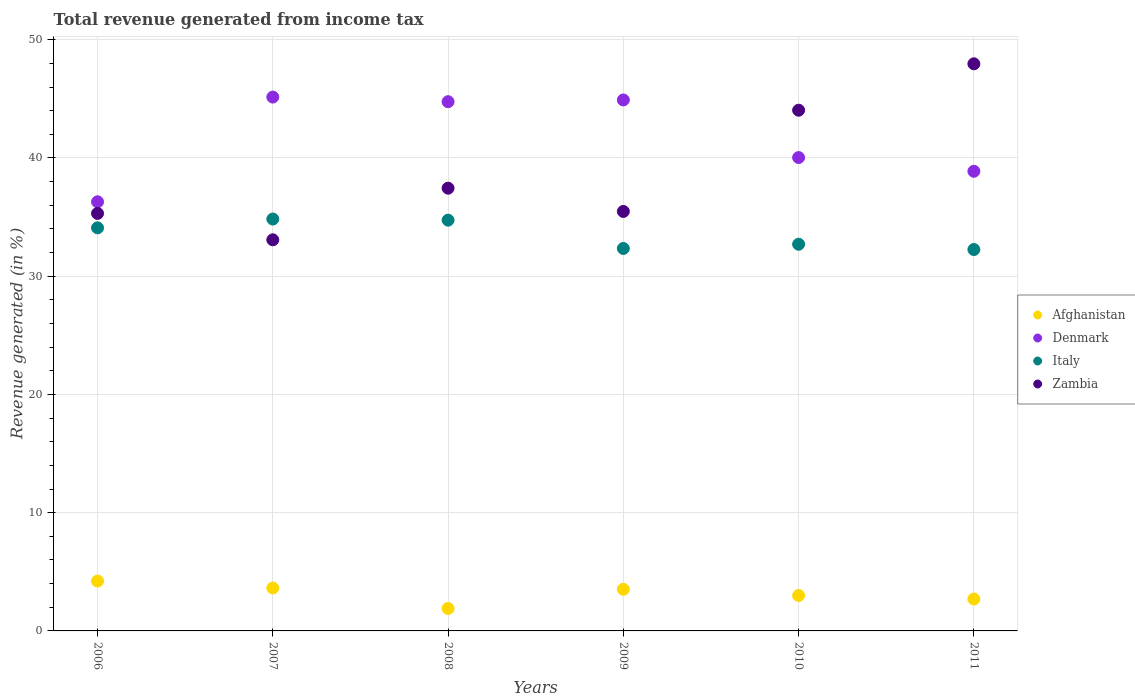Is the number of dotlines equal to the number of legend labels?
Your answer should be very brief. Yes. What is the total revenue generated in Denmark in 2009?
Keep it short and to the point. 44.91. Across all years, what is the maximum total revenue generated in Italy?
Your answer should be very brief. 34.84. Across all years, what is the minimum total revenue generated in Italy?
Keep it short and to the point. 32.26. In which year was the total revenue generated in Denmark maximum?
Your answer should be compact. 2007. In which year was the total revenue generated in Afghanistan minimum?
Provide a short and direct response. 2008. What is the total total revenue generated in Denmark in the graph?
Provide a succinct answer. 250.03. What is the difference between the total revenue generated in Italy in 2006 and that in 2010?
Provide a short and direct response. 1.39. What is the difference between the total revenue generated in Denmark in 2011 and the total revenue generated in Italy in 2010?
Your response must be concise. 6.17. What is the average total revenue generated in Denmark per year?
Your answer should be compact. 41.67. In the year 2011, what is the difference between the total revenue generated in Italy and total revenue generated in Zambia?
Your response must be concise. -15.71. In how many years, is the total revenue generated in Zambia greater than 48 %?
Offer a terse response. 0. What is the ratio of the total revenue generated in Afghanistan in 2007 to that in 2010?
Provide a succinct answer. 1.21. Is the total revenue generated in Zambia in 2006 less than that in 2010?
Give a very brief answer. Yes. What is the difference between the highest and the second highest total revenue generated in Denmark?
Ensure brevity in your answer.  0.24. What is the difference between the highest and the lowest total revenue generated in Italy?
Offer a very short reply. 2.58. Is it the case that in every year, the sum of the total revenue generated in Afghanistan and total revenue generated in Zambia  is greater than the total revenue generated in Italy?
Make the answer very short. Yes. Is the total revenue generated in Italy strictly less than the total revenue generated in Afghanistan over the years?
Offer a very short reply. No. How many dotlines are there?
Provide a short and direct response. 4. Does the graph contain any zero values?
Offer a terse response. No. Does the graph contain grids?
Give a very brief answer. Yes. How are the legend labels stacked?
Ensure brevity in your answer.  Vertical. What is the title of the graph?
Your response must be concise. Total revenue generated from income tax. What is the label or title of the X-axis?
Ensure brevity in your answer.  Years. What is the label or title of the Y-axis?
Offer a terse response. Revenue generated (in %). What is the Revenue generated (in %) of Afghanistan in 2006?
Provide a short and direct response. 4.22. What is the Revenue generated (in %) of Denmark in 2006?
Your answer should be compact. 36.29. What is the Revenue generated (in %) in Italy in 2006?
Offer a very short reply. 34.09. What is the Revenue generated (in %) in Zambia in 2006?
Keep it short and to the point. 35.31. What is the Revenue generated (in %) in Afghanistan in 2007?
Make the answer very short. 3.63. What is the Revenue generated (in %) in Denmark in 2007?
Offer a terse response. 45.15. What is the Revenue generated (in %) of Italy in 2007?
Give a very brief answer. 34.84. What is the Revenue generated (in %) of Zambia in 2007?
Make the answer very short. 33.08. What is the Revenue generated (in %) of Afghanistan in 2008?
Your response must be concise. 1.9. What is the Revenue generated (in %) in Denmark in 2008?
Your answer should be very brief. 44.76. What is the Revenue generated (in %) of Italy in 2008?
Your answer should be very brief. 34.74. What is the Revenue generated (in %) in Zambia in 2008?
Your answer should be very brief. 37.45. What is the Revenue generated (in %) of Afghanistan in 2009?
Offer a very short reply. 3.52. What is the Revenue generated (in %) in Denmark in 2009?
Your answer should be compact. 44.91. What is the Revenue generated (in %) of Italy in 2009?
Give a very brief answer. 32.35. What is the Revenue generated (in %) of Zambia in 2009?
Your answer should be compact. 35.48. What is the Revenue generated (in %) in Afghanistan in 2010?
Make the answer very short. 3. What is the Revenue generated (in %) in Denmark in 2010?
Offer a very short reply. 40.04. What is the Revenue generated (in %) in Italy in 2010?
Make the answer very short. 32.71. What is the Revenue generated (in %) in Zambia in 2010?
Offer a terse response. 44.04. What is the Revenue generated (in %) in Afghanistan in 2011?
Your response must be concise. 2.7. What is the Revenue generated (in %) in Denmark in 2011?
Offer a very short reply. 38.88. What is the Revenue generated (in %) of Italy in 2011?
Provide a short and direct response. 32.26. What is the Revenue generated (in %) in Zambia in 2011?
Provide a succinct answer. 47.97. Across all years, what is the maximum Revenue generated (in %) of Afghanistan?
Your answer should be compact. 4.22. Across all years, what is the maximum Revenue generated (in %) in Denmark?
Provide a short and direct response. 45.15. Across all years, what is the maximum Revenue generated (in %) of Italy?
Make the answer very short. 34.84. Across all years, what is the maximum Revenue generated (in %) of Zambia?
Offer a terse response. 47.97. Across all years, what is the minimum Revenue generated (in %) of Afghanistan?
Ensure brevity in your answer.  1.9. Across all years, what is the minimum Revenue generated (in %) of Denmark?
Your response must be concise. 36.29. Across all years, what is the minimum Revenue generated (in %) in Italy?
Provide a short and direct response. 32.26. Across all years, what is the minimum Revenue generated (in %) in Zambia?
Your answer should be compact. 33.08. What is the total Revenue generated (in %) in Afghanistan in the graph?
Provide a succinct answer. 18.97. What is the total Revenue generated (in %) in Denmark in the graph?
Offer a terse response. 250.03. What is the total Revenue generated (in %) of Italy in the graph?
Offer a terse response. 200.99. What is the total Revenue generated (in %) in Zambia in the graph?
Offer a terse response. 233.33. What is the difference between the Revenue generated (in %) of Afghanistan in 2006 and that in 2007?
Provide a succinct answer. 0.59. What is the difference between the Revenue generated (in %) in Denmark in 2006 and that in 2007?
Keep it short and to the point. -8.86. What is the difference between the Revenue generated (in %) in Italy in 2006 and that in 2007?
Make the answer very short. -0.74. What is the difference between the Revenue generated (in %) in Zambia in 2006 and that in 2007?
Offer a very short reply. 2.23. What is the difference between the Revenue generated (in %) of Afghanistan in 2006 and that in 2008?
Ensure brevity in your answer.  2.32. What is the difference between the Revenue generated (in %) in Denmark in 2006 and that in 2008?
Make the answer very short. -8.47. What is the difference between the Revenue generated (in %) of Italy in 2006 and that in 2008?
Your response must be concise. -0.65. What is the difference between the Revenue generated (in %) of Zambia in 2006 and that in 2008?
Offer a terse response. -2.13. What is the difference between the Revenue generated (in %) of Afghanistan in 2006 and that in 2009?
Offer a very short reply. 0.7. What is the difference between the Revenue generated (in %) in Denmark in 2006 and that in 2009?
Give a very brief answer. -8.61. What is the difference between the Revenue generated (in %) in Italy in 2006 and that in 2009?
Provide a short and direct response. 1.74. What is the difference between the Revenue generated (in %) in Zambia in 2006 and that in 2009?
Provide a succinct answer. -0.17. What is the difference between the Revenue generated (in %) in Afghanistan in 2006 and that in 2010?
Give a very brief answer. 1.22. What is the difference between the Revenue generated (in %) of Denmark in 2006 and that in 2010?
Your response must be concise. -3.74. What is the difference between the Revenue generated (in %) in Italy in 2006 and that in 2010?
Your answer should be very brief. 1.39. What is the difference between the Revenue generated (in %) of Zambia in 2006 and that in 2010?
Provide a short and direct response. -8.73. What is the difference between the Revenue generated (in %) in Afghanistan in 2006 and that in 2011?
Provide a succinct answer. 1.52. What is the difference between the Revenue generated (in %) of Denmark in 2006 and that in 2011?
Your answer should be compact. -2.58. What is the difference between the Revenue generated (in %) of Italy in 2006 and that in 2011?
Ensure brevity in your answer.  1.83. What is the difference between the Revenue generated (in %) of Zambia in 2006 and that in 2011?
Keep it short and to the point. -12.65. What is the difference between the Revenue generated (in %) in Afghanistan in 2007 and that in 2008?
Give a very brief answer. 1.73. What is the difference between the Revenue generated (in %) of Denmark in 2007 and that in 2008?
Make the answer very short. 0.39. What is the difference between the Revenue generated (in %) of Italy in 2007 and that in 2008?
Give a very brief answer. 0.1. What is the difference between the Revenue generated (in %) in Zambia in 2007 and that in 2008?
Ensure brevity in your answer.  -4.37. What is the difference between the Revenue generated (in %) in Afghanistan in 2007 and that in 2009?
Give a very brief answer. 0.11. What is the difference between the Revenue generated (in %) of Denmark in 2007 and that in 2009?
Provide a short and direct response. 0.24. What is the difference between the Revenue generated (in %) in Italy in 2007 and that in 2009?
Your response must be concise. 2.49. What is the difference between the Revenue generated (in %) in Zambia in 2007 and that in 2009?
Give a very brief answer. -2.4. What is the difference between the Revenue generated (in %) in Afghanistan in 2007 and that in 2010?
Provide a succinct answer. 0.63. What is the difference between the Revenue generated (in %) in Denmark in 2007 and that in 2010?
Give a very brief answer. 5.12. What is the difference between the Revenue generated (in %) in Italy in 2007 and that in 2010?
Your response must be concise. 2.13. What is the difference between the Revenue generated (in %) in Zambia in 2007 and that in 2010?
Your response must be concise. -10.96. What is the difference between the Revenue generated (in %) in Afghanistan in 2007 and that in 2011?
Ensure brevity in your answer.  0.94. What is the difference between the Revenue generated (in %) of Denmark in 2007 and that in 2011?
Give a very brief answer. 6.28. What is the difference between the Revenue generated (in %) in Italy in 2007 and that in 2011?
Your answer should be very brief. 2.58. What is the difference between the Revenue generated (in %) in Zambia in 2007 and that in 2011?
Keep it short and to the point. -14.89. What is the difference between the Revenue generated (in %) in Afghanistan in 2008 and that in 2009?
Your answer should be compact. -1.62. What is the difference between the Revenue generated (in %) of Denmark in 2008 and that in 2009?
Provide a succinct answer. -0.15. What is the difference between the Revenue generated (in %) of Italy in 2008 and that in 2009?
Give a very brief answer. 2.39. What is the difference between the Revenue generated (in %) in Zambia in 2008 and that in 2009?
Provide a succinct answer. 1.97. What is the difference between the Revenue generated (in %) of Afghanistan in 2008 and that in 2010?
Your answer should be very brief. -1.1. What is the difference between the Revenue generated (in %) in Denmark in 2008 and that in 2010?
Your answer should be very brief. 4.73. What is the difference between the Revenue generated (in %) in Italy in 2008 and that in 2010?
Your answer should be compact. 2.04. What is the difference between the Revenue generated (in %) in Zambia in 2008 and that in 2010?
Ensure brevity in your answer.  -6.6. What is the difference between the Revenue generated (in %) of Afghanistan in 2008 and that in 2011?
Make the answer very short. -0.8. What is the difference between the Revenue generated (in %) of Denmark in 2008 and that in 2011?
Give a very brief answer. 5.88. What is the difference between the Revenue generated (in %) in Italy in 2008 and that in 2011?
Make the answer very short. 2.48. What is the difference between the Revenue generated (in %) of Zambia in 2008 and that in 2011?
Ensure brevity in your answer.  -10.52. What is the difference between the Revenue generated (in %) in Afghanistan in 2009 and that in 2010?
Your answer should be compact. 0.52. What is the difference between the Revenue generated (in %) of Denmark in 2009 and that in 2010?
Provide a short and direct response. 4.87. What is the difference between the Revenue generated (in %) in Italy in 2009 and that in 2010?
Your answer should be compact. -0.36. What is the difference between the Revenue generated (in %) in Zambia in 2009 and that in 2010?
Give a very brief answer. -8.56. What is the difference between the Revenue generated (in %) of Afghanistan in 2009 and that in 2011?
Keep it short and to the point. 0.82. What is the difference between the Revenue generated (in %) in Denmark in 2009 and that in 2011?
Offer a very short reply. 6.03. What is the difference between the Revenue generated (in %) in Italy in 2009 and that in 2011?
Your response must be concise. 0.09. What is the difference between the Revenue generated (in %) of Zambia in 2009 and that in 2011?
Offer a very short reply. -12.49. What is the difference between the Revenue generated (in %) of Afghanistan in 2010 and that in 2011?
Offer a very short reply. 0.3. What is the difference between the Revenue generated (in %) in Denmark in 2010 and that in 2011?
Provide a succinct answer. 1.16. What is the difference between the Revenue generated (in %) of Italy in 2010 and that in 2011?
Your response must be concise. 0.45. What is the difference between the Revenue generated (in %) of Zambia in 2010 and that in 2011?
Your answer should be very brief. -3.92. What is the difference between the Revenue generated (in %) of Afghanistan in 2006 and the Revenue generated (in %) of Denmark in 2007?
Provide a succinct answer. -40.93. What is the difference between the Revenue generated (in %) of Afghanistan in 2006 and the Revenue generated (in %) of Italy in 2007?
Provide a succinct answer. -30.62. What is the difference between the Revenue generated (in %) in Afghanistan in 2006 and the Revenue generated (in %) in Zambia in 2007?
Provide a succinct answer. -28.86. What is the difference between the Revenue generated (in %) of Denmark in 2006 and the Revenue generated (in %) of Italy in 2007?
Give a very brief answer. 1.46. What is the difference between the Revenue generated (in %) of Denmark in 2006 and the Revenue generated (in %) of Zambia in 2007?
Provide a short and direct response. 3.21. What is the difference between the Revenue generated (in %) in Italy in 2006 and the Revenue generated (in %) in Zambia in 2007?
Offer a terse response. 1.01. What is the difference between the Revenue generated (in %) in Afghanistan in 2006 and the Revenue generated (in %) in Denmark in 2008?
Provide a short and direct response. -40.54. What is the difference between the Revenue generated (in %) of Afghanistan in 2006 and the Revenue generated (in %) of Italy in 2008?
Offer a terse response. -30.52. What is the difference between the Revenue generated (in %) in Afghanistan in 2006 and the Revenue generated (in %) in Zambia in 2008?
Your answer should be compact. -33.23. What is the difference between the Revenue generated (in %) in Denmark in 2006 and the Revenue generated (in %) in Italy in 2008?
Your response must be concise. 1.55. What is the difference between the Revenue generated (in %) in Denmark in 2006 and the Revenue generated (in %) in Zambia in 2008?
Provide a succinct answer. -1.15. What is the difference between the Revenue generated (in %) of Italy in 2006 and the Revenue generated (in %) of Zambia in 2008?
Give a very brief answer. -3.35. What is the difference between the Revenue generated (in %) in Afghanistan in 2006 and the Revenue generated (in %) in Denmark in 2009?
Offer a terse response. -40.69. What is the difference between the Revenue generated (in %) of Afghanistan in 2006 and the Revenue generated (in %) of Italy in 2009?
Your answer should be very brief. -28.13. What is the difference between the Revenue generated (in %) in Afghanistan in 2006 and the Revenue generated (in %) in Zambia in 2009?
Your answer should be very brief. -31.26. What is the difference between the Revenue generated (in %) in Denmark in 2006 and the Revenue generated (in %) in Italy in 2009?
Your answer should be compact. 3.95. What is the difference between the Revenue generated (in %) in Denmark in 2006 and the Revenue generated (in %) in Zambia in 2009?
Your answer should be compact. 0.82. What is the difference between the Revenue generated (in %) in Italy in 2006 and the Revenue generated (in %) in Zambia in 2009?
Ensure brevity in your answer.  -1.39. What is the difference between the Revenue generated (in %) of Afghanistan in 2006 and the Revenue generated (in %) of Denmark in 2010?
Offer a terse response. -35.82. What is the difference between the Revenue generated (in %) in Afghanistan in 2006 and the Revenue generated (in %) in Italy in 2010?
Give a very brief answer. -28.49. What is the difference between the Revenue generated (in %) of Afghanistan in 2006 and the Revenue generated (in %) of Zambia in 2010?
Offer a terse response. -39.82. What is the difference between the Revenue generated (in %) of Denmark in 2006 and the Revenue generated (in %) of Italy in 2010?
Offer a terse response. 3.59. What is the difference between the Revenue generated (in %) of Denmark in 2006 and the Revenue generated (in %) of Zambia in 2010?
Make the answer very short. -7.75. What is the difference between the Revenue generated (in %) in Italy in 2006 and the Revenue generated (in %) in Zambia in 2010?
Your response must be concise. -9.95. What is the difference between the Revenue generated (in %) of Afghanistan in 2006 and the Revenue generated (in %) of Denmark in 2011?
Give a very brief answer. -34.66. What is the difference between the Revenue generated (in %) in Afghanistan in 2006 and the Revenue generated (in %) in Italy in 2011?
Your answer should be compact. -28.04. What is the difference between the Revenue generated (in %) in Afghanistan in 2006 and the Revenue generated (in %) in Zambia in 2011?
Keep it short and to the point. -43.75. What is the difference between the Revenue generated (in %) of Denmark in 2006 and the Revenue generated (in %) of Italy in 2011?
Make the answer very short. 4.04. What is the difference between the Revenue generated (in %) in Denmark in 2006 and the Revenue generated (in %) in Zambia in 2011?
Offer a terse response. -11.67. What is the difference between the Revenue generated (in %) in Italy in 2006 and the Revenue generated (in %) in Zambia in 2011?
Provide a succinct answer. -13.87. What is the difference between the Revenue generated (in %) in Afghanistan in 2007 and the Revenue generated (in %) in Denmark in 2008?
Your response must be concise. -41.13. What is the difference between the Revenue generated (in %) of Afghanistan in 2007 and the Revenue generated (in %) of Italy in 2008?
Offer a very short reply. -31.11. What is the difference between the Revenue generated (in %) of Afghanistan in 2007 and the Revenue generated (in %) of Zambia in 2008?
Provide a short and direct response. -33.81. What is the difference between the Revenue generated (in %) in Denmark in 2007 and the Revenue generated (in %) in Italy in 2008?
Your response must be concise. 10.41. What is the difference between the Revenue generated (in %) in Denmark in 2007 and the Revenue generated (in %) in Zambia in 2008?
Offer a very short reply. 7.71. What is the difference between the Revenue generated (in %) of Italy in 2007 and the Revenue generated (in %) of Zambia in 2008?
Ensure brevity in your answer.  -2.61. What is the difference between the Revenue generated (in %) of Afghanistan in 2007 and the Revenue generated (in %) of Denmark in 2009?
Your answer should be very brief. -41.28. What is the difference between the Revenue generated (in %) in Afghanistan in 2007 and the Revenue generated (in %) in Italy in 2009?
Your answer should be compact. -28.72. What is the difference between the Revenue generated (in %) in Afghanistan in 2007 and the Revenue generated (in %) in Zambia in 2009?
Ensure brevity in your answer.  -31.85. What is the difference between the Revenue generated (in %) of Denmark in 2007 and the Revenue generated (in %) of Italy in 2009?
Offer a terse response. 12.8. What is the difference between the Revenue generated (in %) of Denmark in 2007 and the Revenue generated (in %) of Zambia in 2009?
Ensure brevity in your answer.  9.67. What is the difference between the Revenue generated (in %) of Italy in 2007 and the Revenue generated (in %) of Zambia in 2009?
Provide a succinct answer. -0.64. What is the difference between the Revenue generated (in %) of Afghanistan in 2007 and the Revenue generated (in %) of Denmark in 2010?
Provide a succinct answer. -36.4. What is the difference between the Revenue generated (in %) in Afghanistan in 2007 and the Revenue generated (in %) in Italy in 2010?
Keep it short and to the point. -29.07. What is the difference between the Revenue generated (in %) in Afghanistan in 2007 and the Revenue generated (in %) in Zambia in 2010?
Ensure brevity in your answer.  -40.41. What is the difference between the Revenue generated (in %) of Denmark in 2007 and the Revenue generated (in %) of Italy in 2010?
Offer a terse response. 12.45. What is the difference between the Revenue generated (in %) in Denmark in 2007 and the Revenue generated (in %) in Zambia in 2010?
Your answer should be very brief. 1.11. What is the difference between the Revenue generated (in %) in Italy in 2007 and the Revenue generated (in %) in Zambia in 2010?
Offer a terse response. -9.2. What is the difference between the Revenue generated (in %) in Afghanistan in 2007 and the Revenue generated (in %) in Denmark in 2011?
Make the answer very short. -35.24. What is the difference between the Revenue generated (in %) in Afghanistan in 2007 and the Revenue generated (in %) in Italy in 2011?
Your answer should be very brief. -28.63. What is the difference between the Revenue generated (in %) in Afghanistan in 2007 and the Revenue generated (in %) in Zambia in 2011?
Your answer should be very brief. -44.33. What is the difference between the Revenue generated (in %) in Denmark in 2007 and the Revenue generated (in %) in Italy in 2011?
Make the answer very short. 12.89. What is the difference between the Revenue generated (in %) in Denmark in 2007 and the Revenue generated (in %) in Zambia in 2011?
Ensure brevity in your answer.  -2.81. What is the difference between the Revenue generated (in %) of Italy in 2007 and the Revenue generated (in %) of Zambia in 2011?
Your answer should be very brief. -13.13. What is the difference between the Revenue generated (in %) of Afghanistan in 2008 and the Revenue generated (in %) of Denmark in 2009?
Provide a short and direct response. -43.01. What is the difference between the Revenue generated (in %) of Afghanistan in 2008 and the Revenue generated (in %) of Italy in 2009?
Provide a short and direct response. -30.45. What is the difference between the Revenue generated (in %) in Afghanistan in 2008 and the Revenue generated (in %) in Zambia in 2009?
Offer a terse response. -33.58. What is the difference between the Revenue generated (in %) of Denmark in 2008 and the Revenue generated (in %) of Italy in 2009?
Your answer should be very brief. 12.41. What is the difference between the Revenue generated (in %) in Denmark in 2008 and the Revenue generated (in %) in Zambia in 2009?
Keep it short and to the point. 9.28. What is the difference between the Revenue generated (in %) in Italy in 2008 and the Revenue generated (in %) in Zambia in 2009?
Provide a succinct answer. -0.74. What is the difference between the Revenue generated (in %) of Afghanistan in 2008 and the Revenue generated (in %) of Denmark in 2010?
Your answer should be compact. -38.14. What is the difference between the Revenue generated (in %) in Afghanistan in 2008 and the Revenue generated (in %) in Italy in 2010?
Make the answer very short. -30.81. What is the difference between the Revenue generated (in %) of Afghanistan in 2008 and the Revenue generated (in %) of Zambia in 2010?
Offer a very short reply. -42.14. What is the difference between the Revenue generated (in %) of Denmark in 2008 and the Revenue generated (in %) of Italy in 2010?
Make the answer very short. 12.06. What is the difference between the Revenue generated (in %) in Denmark in 2008 and the Revenue generated (in %) in Zambia in 2010?
Offer a terse response. 0.72. What is the difference between the Revenue generated (in %) in Italy in 2008 and the Revenue generated (in %) in Zambia in 2010?
Your answer should be very brief. -9.3. What is the difference between the Revenue generated (in %) in Afghanistan in 2008 and the Revenue generated (in %) in Denmark in 2011?
Your answer should be very brief. -36.98. What is the difference between the Revenue generated (in %) in Afghanistan in 2008 and the Revenue generated (in %) in Italy in 2011?
Give a very brief answer. -30.36. What is the difference between the Revenue generated (in %) of Afghanistan in 2008 and the Revenue generated (in %) of Zambia in 2011?
Give a very brief answer. -46.07. What is the difference between the Revenue generated (in %) in Denmark in 2008 and the Revenue generated (in %) in Italy in 2011?
Make the answer very short. 12.5. What is the difference between the Revenue generated (in %) of Denmark in 2008 and the Revenue generated (in %) of Zambia in 2011?
Provide a short and direct response. -3.2. What is the difference between the Revenue generated (in %) in Italy in 2008 and the Revenue generated (in %) in Zambia in 2011?
Give a very brief answer. -13.22. What is the difference between the Revenue generated (in %) of Afghanistan in 2009 and the Revenue generated (in %) of Denmark in 2010?
Provide a short and direct response. -36.52. What is the difference between the Revenue generated (in %) in Afghanistan in 2009 and the Revenue generated (in %) in Italy in 2010?
Your answer should be compact. -29.19. What is the difference between the Revenue generated (in %) in Afghanistan in 2009 and the Revenue generated (in %) in Zambia in 2010?
Give a very brief answer. -40.52. What is the difference between the Revenue generated (in %) in Denmark in 2009 and the Revenue generated (in %) in Italy in 2010?
Your answer should be very brief. 12.2. What is the difference between the Revenue generated (in %) in Denmark in 2009 and the Revenue generated (in %) in Zambia in 2010?
Provide a succinct answer. 0.87. What is the difference between the Revenue generated (in %) of Italy in 2009 and the Revenue generated (in %) of Zambia in 2010?
Provide a short and direct response. -11.69. What is the difference between the Revenue generated (in %) in Afghanistan in 2009 and the Revenue generated (in %) in Denmark in 2011?
Keep it short and to the point. -35.36. What is the difference between the Revenue generated (in %) of Afghanistan in 2009 and the Revenue generated (in %) of Italy in 2011?
Your answer should be very brief. -28.74. What is the difference between the Revenue generated (in %) in Afghanistan in 2009 and the Revenue generated (in %) in Zambia in 2011?
Give a very brief answer. -44.45. What is the difference between the Revenue generated (in %) of Denmark in 2009 and the Revenue generated (in %) of Italy in 2011?
Your answer should be compact. 12.65. What is the difference between the Revenue generated (in %) in Denmark in 2009 and the Revenue generated (in %) in Zambia in 2011?
Give a very brief answer. -3.06. What is the difference between the Revenue generated (in %) of Italy in 2009 and the Revenue generated (in %) of Zambia in 2011?
Your answer should be very brief. -15.62. What is the difference between the Revenue generated (in %) in Afghanistan in 2010 and the Revenue generated (in %) in Denmark in 2011?
Your response must be concise. -35.88. What is the difference between the Revenue generated (in %) of Afghanistan in 2010 and the Revenue generated (in %) of Italy in 2011?
Provide a short and direct response. -29.26. What is the difference between the Revenue generated (in %) of Afghanistan in 2010 and the Revenue generated (in %) of Zambia in 2011?
Offer a terse response. -44.97. What is the difference between the Revenue generated (in %) of Denmark in 2010 and the Revenue generated (in %) of Italy in 2011?
Offer a very short reply. 7.78. What is the difference between the Revenue generated (in %) in Denmark in 2010 and the Revenue generated (in %) in Zambia in 2011?
Your answer should be compact. -7.93. What is the difference between the Revenue generated (in %) in Italy in 2010 and the Revenue generated (in %) in Zambia in 2011?
Provide a short and direct response. -15.26. What is the average Revenue generated (in %) in Afghanistan per year?
Provide a succinct answer. 3.16. What is the average Revenue generated (in %) of Denmark per year?
Ensure brevity in your answer.  41.67. What is the average Revenue generated (in %) of Italy per year?
Give a very brief answer. 33.5. What is the average Revenue generated (in %) in Zambia per year?
Keep it short and to the point. 38.89. In the year 2006, what is the difference between the Revenue generated (in %) in Afghanistan and Revenue generated (in %) in Denmark?
Ensure brevity in your answer.  -32.08. In the year 2006, what is the difference between the Revenue generated (in %) in Afghanistan and Revenue generated (in %) in Italy?
Give a very brief answer. -29.87. In the year 2006, what is the difference between the Revenue generated (in %) of Afghanistan and Revenue generated (in %) of Zambia?
Make the answer very short. -31.09. In the year 2006, what is the difference between the Revenue generated (in %) of Denmark and Revenue generated (in %) of Italy?
Give a very brief answer. 2.2. In the year 2006, what is the difference between the Revenue generated (in %) in Italy and Revenue generated (in %) in Zambia?
Offer a terse response. -1.22. In the year 2007, what is the difference between the Revenue generated (in %) of Afghanistan and Revenue generated (in %) of Denmark?
Your response must be concise. -41.52. In the year 2007, what is the difference between the Revenue generated (in %) in Afghanistan and Revenue generated (in %) in Italy?
Offer a very short reply. -31.2. In the year 2007, what is the difference between the Revenue generated (in %) in Afghanistan and Revenue generated (in %) in Zambia?
Make the answer very short. -29.45. In the year 2007, what is the difference between the Revenue generated (in %) of Denmark and Revenue generated (in %) of Italy?
Keep it short and to the point. 10.32. In the year 2007, what is the difference between the Revenue generated (in %) in Denmark and Revenue generated (in %) in Zambia?
Provide a succinct answer. 12.07. In the year 2007, what is the difference between the Revenue generated (in %) in Italy and Revenue generated (in %) in Zambia?
Provide a short and direct response. 1.76. In the year 2008, what is the difference between the Revenue generated (in %) of Afghanistan and Revenue generated (in %) of Denmark?
Offer a very short reply. -42.86. In the year 2008, what is the difference between the Revenue generated (in %) of Afghanistan and Revenue generated (in %) of Italy?
Give a very brief answer. -32.84. In the year 2008, what is the difference between the Revenue generated (in %) of Afghanistan and Revenue generated (in %) of Zambia?
Offer a terse response. -35.55. In the year 2008, what is the difference between the Revenue generated (in %) of Denmark and Revenue generated (in %) of Italy?
Give a very brief answer. 10.02. In the year 2008, what is the difference between the Revenue generated (in %) of Denmark and Revenue generated (in %) of Zambia?
Your answer should be compact. 7.32. In the year 2008, what is the difference between the Revenue generated (in %) in Italy and Revenue generated (in %) in Zambia?
Make the answer very short. -2.7. In the year 2009, what is the difference between the Revenue generated (in %) in Afghanistan and Revenue generated (in %) in Denmark?
Provide a short and direct response. -41.39. In the year 2009, what is the difference between the Revenue generated (in %) in Afghanistan and Revenue generated (in %) in Italy?
Your answer should be very brief. -28.83. In the year 2009, what is the difference between the Revenue generated (in %) of Afghanistan and Revenue generated (in %) of Zambia?
Provide a succinct answer. -31.96. In the year 2009, what is the difference between the Revenue generated (in %) in Denmark and Revenue generated (in %) in Italy?
Keep it short and to the point. 12.56. In the year 2009, what is the difference between the Revenue generated (in %) in Denmark and Revenue generated (in %) in Zambia?
Keep it short and to the point. 9.43. In the year 2009, what is the difference between the Revenue generated (in %) in Italy and Revenue generated (in %) in Zambia?
Your answer should be compact. -3.13. In the year 2010, what is the difference between the Revenue generated (in %) of Afghanistan and Revenue generated (in %) of Denmark?
Offer a very short reply. -37.04. In the year 2010, what is the difference between the Revenue generated (in %) of Afghanistan and Revenue generated (in %) of Italy?
Provide a succinct answer. -29.71. In the year 2010, what is the difference between the Revenue generated (in %) of Afghanistan and Revenue generated (in %) of Zambia?
Offer a very short reply. -41.04. In the year 2010, what is the difference between the Revenue generated (in %) in Denmark and Revenue generated (in %) in Italy?
Provide a short and direct response. 7.33. In the year 2010, what is the difference between the Revenue generated (in %) in Denmark and Revenue generated (in %) in Zambia?
Your answer should be very brief. -4.01. In the year 2010, what is the difference between the Revenue generated (in %) in Italy and Revenue generated (in %) in Zambia?
Keep it short and to the point. -11.34. In the year 2011, what is the difference between the Revenue generated (in %) of Afghanistan and Revenue generated (in %) of Denmark?
Give a very brief answer. -36.18. In the year 2011, what is the difference between the Revenue generated (in %) of Afghanistan and Revenue generated (in %) of Italy?
Provide a succinct answer. -29.56. In the year 2011, what is the difference between the Revenue generated (in %) of Afghanistan and Revenue generated (in %) of Zambia?
Ensure brevity in your answer.  -45.27. In the year 2011, what is the difference between the Revenue generated (in %) in Denmark and Revenue generated (in %) in Italy?
Your response must be concise. 6.62. In the year 2011, what is the difference between the Revenue generated (in %) of Denmark and Revenue generated (in %) of Zambia?
Your answer should be compact. -9.09. In the year 2011, what is the difference between the Revenue generated (in %) of Italy and Revenue generated (in %) of Zambia?
Your answer should be very brief. -15.71. What is the ratio of the Revenue generated (in %) of Afghanistan in 2006 to that in 2007?
Your answer should be compact. 1.16. What is the ratio of the Revenue generated (in %) in Denmark in 2006 to that in 2007?
Offer a terse response. 0.8. What is the ratio of the Revenue generated (in %) in Italy in 2006 to that in 2007?
Provide a short and direct response. 0.98. What is the ratio of the Revenue generated (in %) of Zambia in 2006 to that in 2007?
Provide a short and direct response. 1.07. What is the ratio of the Revenue generated (in %) in Afghanistan in 2006 to that in 2008?
Offer a very short reply. 2.22. What is the ratio of the Revenue generated (in %) of Denmark in 2006 to that in 2008?
Offer a very short reply. 0.81. What is the ratio of the Revenue generated (in %) of Italy in 2006 to that in 2008?
Your answer should be very brief. 0.98. What is the ratio of the Revenue generated (in %) of Zambia in 2006 to that in 2008?
Ensure brevity in your answer.  0.94. What is the ratio of the Revenue generated (in %) of Afghanistan in 2006 to that in 2009?
Your response must be concise. 1.2. What is the ratio of the Revenue generated (in %) in Denmark in 2006 to that in 2009?
Your response must be concise. 0.81. What is the ratio of the Revenue generated (in %) in Italy in 2006 to that in 2009?
Your response must be concise. 1.05. What is the ratio of the Revenue generated (in %) of Afghanistan in 2006 to that in 2010?
Your response must be concise. 1.41. What is the ratio of the Revenue generated (in %) of Denmark in 2006 to that in 2010?
Keep it short and to the point. 0.91. What is the ratio of the Revenue generated (in %) in Italy in 2006 to that in 2010?
Offer a very short reply. 1.04. What is the ratio of the Revenue generated (in %) of Zambia in 2006 to that in 2010?
Your answer should be compact. 0.8. What is the ratio of the Revenue generated (in %) in Afghanistan in 2006 to that in 2011?
Your answer should be very brief. 1.56. What is the ratio of the Revenue generated (in %) in Denmark in 2006 to that in 2011?
Offer a very short reply. 0.93. What is the ratio of the Revenue generated (in %) of Italy in 2006 to that in 2011?
Give a very brief answer. 1.06. What is the ratio of the Revenue generated (in %) in Zambia in 2006 to that in 2011?
Your answer should be compact. 0.74. What is the ratio of the Revenue generated (in %) of Afghanistan in 2007 to that in 2008?
Your response must be concise. 1.91. What is the ratio of the Revenue generated (in %) in Denmark in 2007 to that in 2008?
Keep it short and to the point. 1.01. What is the ratio of the Revenue generated (in %) in Zambia in 2007 to that in 2008?
Make the answer very short. 0.88. What is the ratio of the Revenue generated (in %) of Afghanistan in 2007 to that in 2009?
Offer a very short reply. 1.03. What is the ratio of the Revenue generated (in %) in Denmark in 2007 to that in 2009?
Offer a very short reply. 1.01. What is the ratio of the Revenue generated (in %) in Italy in 2007 to that in 2009?
Make the answer very short. 1.08. What is the ratio of the Revenue generated (in %) in Zambia in 2007 to that in 2009?
Provide a succinct answer. 0.93. What is the ratio of the Revenue generated (in %) in Afghanistan in 2007 to that in 2010?
Your answer should be very brief. 1.21. What is the ratio of the Revenue generated (in %) in Denmark in 2007 to that in 2010?
Ensure brevity in your answer.  1.13. What is the ratio of the Revenue generated (in %) of Italy in 2007 to that in 2010?
Offer a terse response. 1.07. What is the ratio of the Revenue generated (in %) of Zambia in 2007 to that in 2010?
Your answer should be very brief. 0.75. What is the ratio of the Revenue generated (in %) in Afghanistan in 2007 to that in 2011?
Ensure brevity in your answer.  1.35. What is the ratio of the Revenue generated (in %) in Denmark in 2007 to that in 2011?
Offer a terse response. 1.16. What is the ratio of the Revenue generated (in %) of Italy in 2007 to that in 2011?
Provide a succinct answer. 1.08. What is the ratio of the Revenue generated (in %) of Zambia in 2007 to that in 2011?
Offer a very short reply. 0.69. What is the ratio of the Revenue generated (in %) of Afghanistan in 2008 to that in 2009?
Provide a short and direct response. 0.54. What is the ratio of the Revenue generated (in %) of Italy in 2008 to that in 2009?
Keep it short and to the point. 1.07. What is the ratio of the Revenue generated (in %) in Zambia in 2008 to that in 2009?
Ensure brevity in your answer.  1.06. What is the ratio of the Revenue generated (in %) of Afghanistan in 2008 to that in 2010?
Provide a short and direct response. 0.63. What is the ratio of the Revenue generated (in %) of Denmark in 2008 to that in 2010?
Provide a succinct answer. 1.12. What is the ratio of the Revenue generated (in %) of Italy in 2008 to that in 2010?
Make the answer very short. 1.06. What is the ratio of the Revenue generated (in %) of Zambia in 2008 to that in 2010?
Provide a succinct answer. 0.85. What is the ratio of the Revenue generated (in %) in Afghanistan in 2008 to that in 2011?
Provide a succinct answer. 0.7. What is the ratio of the Revenue generated (in %) in Denmark in 2008 to that in 2011?
Offer a terse response. 1.15. What is the ratio of the Revenue generated (in %) of Italy in 2008 to that in 2011?
Offer a very short reply. 1.08. What is the ratio of the Revenue generated (in %) in Zambia in 2008 to that in 2011?
Your response must be concise. 0.78. What is the ratio of the Revenue generated (in %) of Afghanistan in 2009 to that in 2010?
Provide a succinct answer. 1.17. What is the ratio of the Revenue generated (in %) of Denmark in 2009 to that in 2010?
Provide a succinct answer. 1.12. What is the ratio of the Revenue generated (in %) in Zambia in 2009 to that in 2010?
Make the answer very short. 0.81. What is the ratio of the Revenue generated (in %) in Afghanistan in 2009 to that in 2011?
Make the answer very short. 1.31. What is the ratio of the Revenue generated (in %) of Denmark in 2009 to that in 2011?
Your response must be concise. 1.16. What is the ratio of the Revenue generated (in %) of Zambia in 2009 to that in 2011?
Offer a very short reply. 0.74. What is the ratio of the Revenue generated (in %) in Afghanistan in 2010 to that in 2011?
Offer a terse response. 1.11. What is the ratio of the Revenue generated (in %) in Denmark in 2010 to that in 2011?
Your answer should be very brief. 1.03. What is the ratio of the Revenue generated (in %) in Italy in 2010 to that in 2011?
Your answer should be very brief. 1.01. What is the ratio of the Revenue generated (in %) in Zambia in 2010 to that in 2011?
Keep it short and to the point. 0.92. What is the difference between the highest and the second highest Revenue generated (in %) of Afghanistan?
Make the answer very short. 0.59. What is the difference between the highest and the second highest Revenue generated (in %) of Denmark?
Offer a terse response. 0.24. What is the difference between the highest and the second highest Revenue generated (in %) in Italy?
Ensure brevity in your answer.  0.1. What is the difference between the highest and the second highest Revenue generated (in %) of Zambia?
Offer a very short reply. 3.92. What is the difference between the highest and the lowest Revenue generated (in %) of Afghanistan?
Make the answer very short. 2.32. What is the difference between the highest and the lowest Revenue generated (in %) of Denmark?
Provide a succinct answer. 8.86. What is the difference between the highest and the lowest Revenue generated (in %) of Italy?
Offer a terse response. 2.58. What is the difference between the highest and the lowest Revenue generated (in %) of Zambia?
Your answer should be compact. 14.89. 